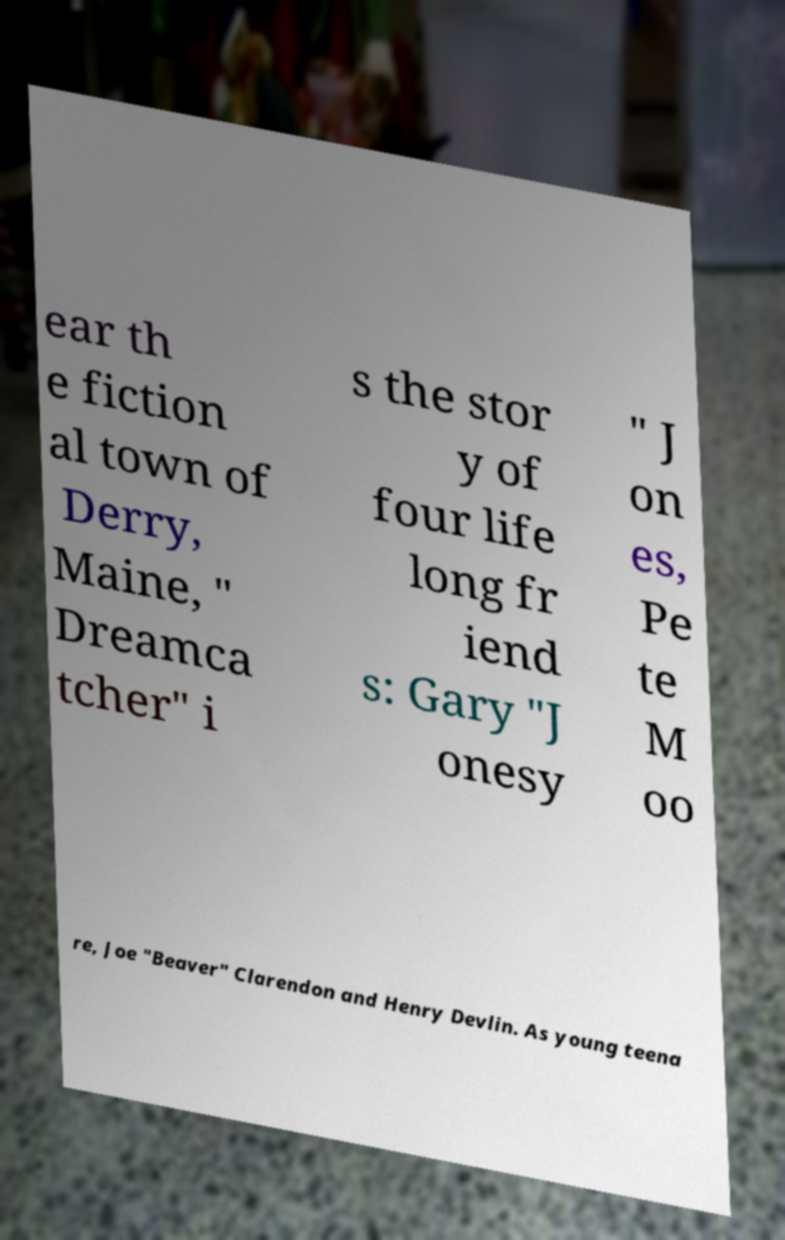Can you accurately transcribe the text from the provided image for me? ear th e fiction al town of Derry, Maine, " Dreamca tcher" i s the stor y of four life long fr iend s: Gary "J onesy " J on es, Pe te M oo re, Joe "Beaver" Clarendon and Henry Devlin. As young teena 